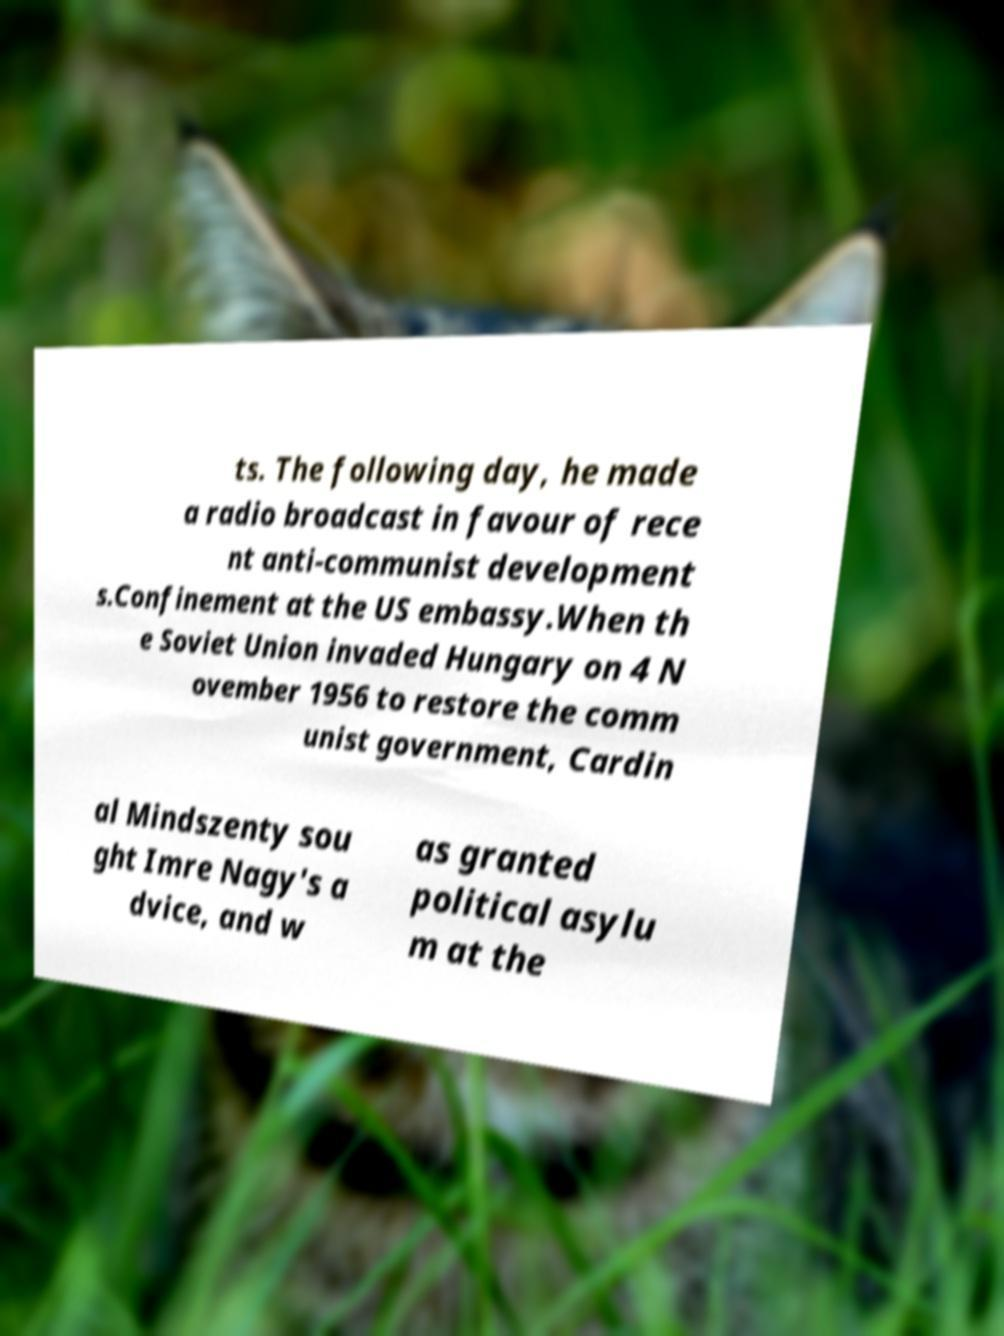There's text embedded in this image that I need extracted. Can you transcribe it verbatim? ts. The following day, he made a radio broadcast in favour of rece nt anti-communist development s.Confinement at the US embassy.When th e Soviet Union invaded Hungary on 4 N ovember 1956 to restore the comm unist government, Cardin al Mindszenty sou ght Imre Nagy's a dvice, and w as granted political asylu m at the 